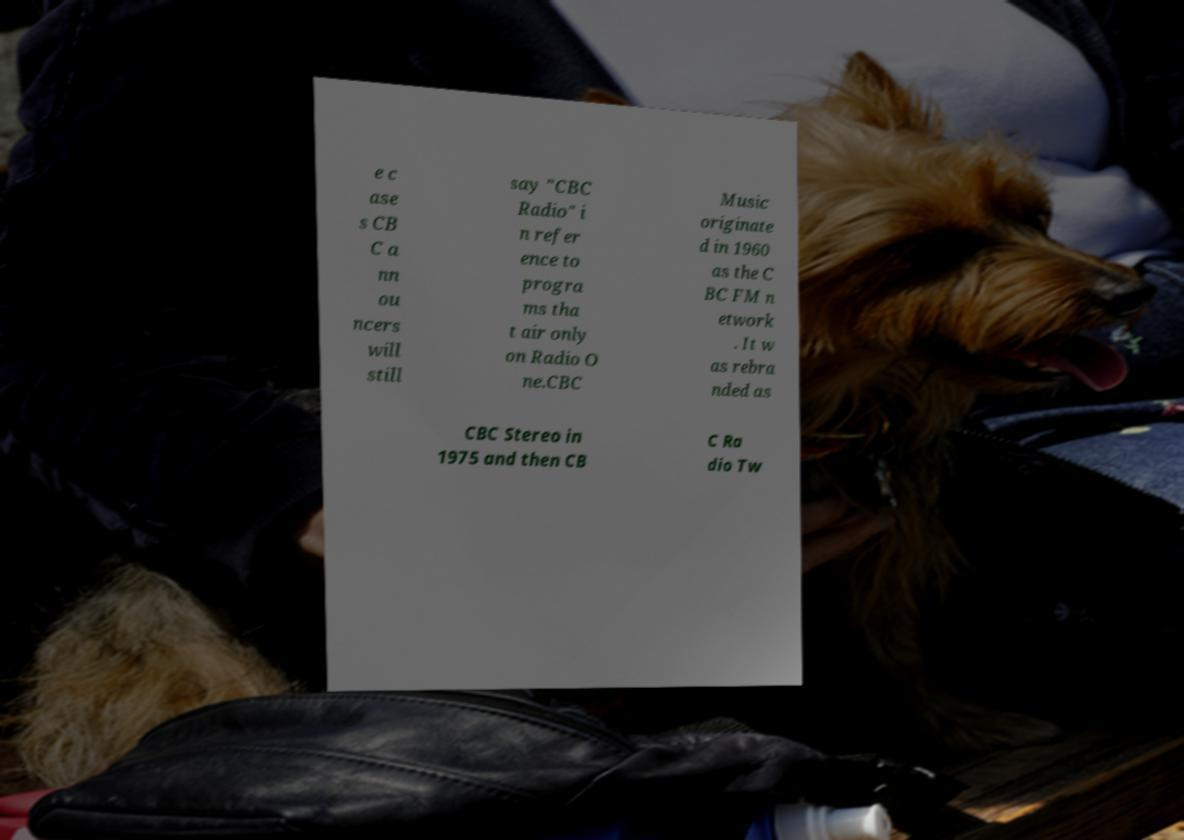I need the written content from this picture converted into text. Can you do that? e c ase s CB C a nn ou ncers will still say "CBC Radio" i n refer ence to progra ms tha t air only on Radio O ne.CBC Music originate d in 1960 as the C BC FM n etwork . It w as rebra nded as CBC Stereo in 1975 and then CB C Ra dio Tw 